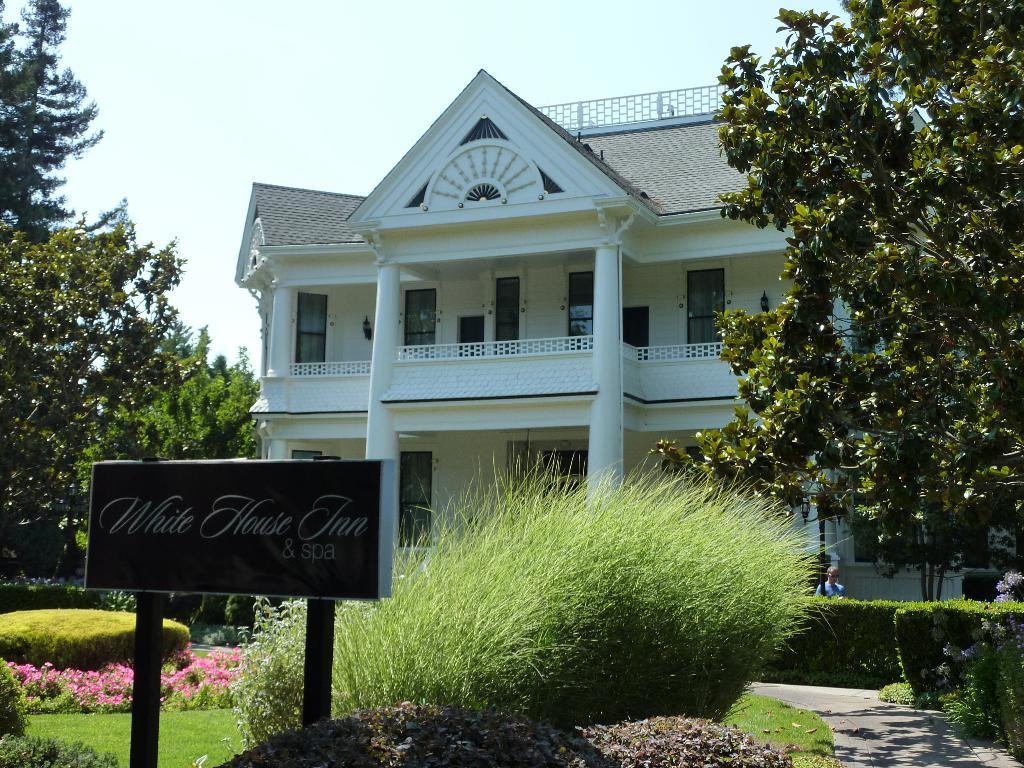What type of structure is present in the image? There is a building in the image. What type of vegetation can be seen in the image? There are bushes, flowers, shrubs, and trees in the image. What is the purpose of the name board in the image? The name board in the image provides information about the building or location. What is the condition of the sky in the image? The sky is visible in the image. What type of print can be seen on the person's knee in the image? There is no person with a knee visible in the image, and therefore no print can be observed. What is the person's reaction to the disgusting smell in the image? There is no indication of a disgusting smell or any reaction from a person in the image. 